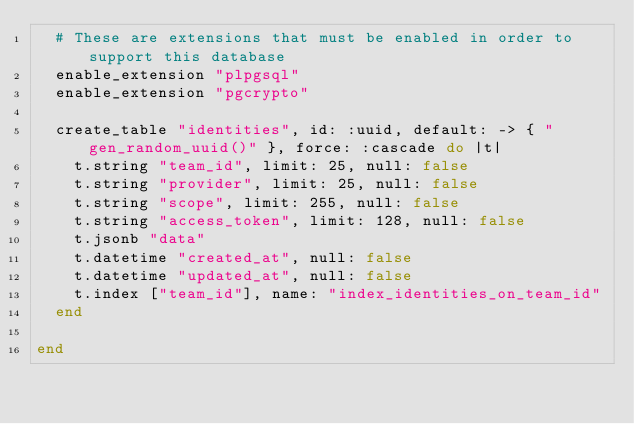Convert code to text. <code><loc_0><loc_0><loc_500><loc_500><_Ruby_>  # These are extensions that must be enabled in order to support this database
  enable_extension "plpgsql"
  enable_extension "pgcrypto"

  create_table "identities", id: :uuid, default: -> { "gen_random_uuid()" }, force: :cascade do |t|
    t.string "team_id", limit: 25, null: false
    t.string "provider", limit: 25, null: false
    t.string "scope", limit: 255, null: false
    t.string "access_token", limit: 128, null: false
    t.jsonb "data"
    t.datetime "created_at", null: false
    t.datetime "updated_at", null: false
    t.index ["team_id"], name: "index_identities_on_team_id"
  end

end
</code> 